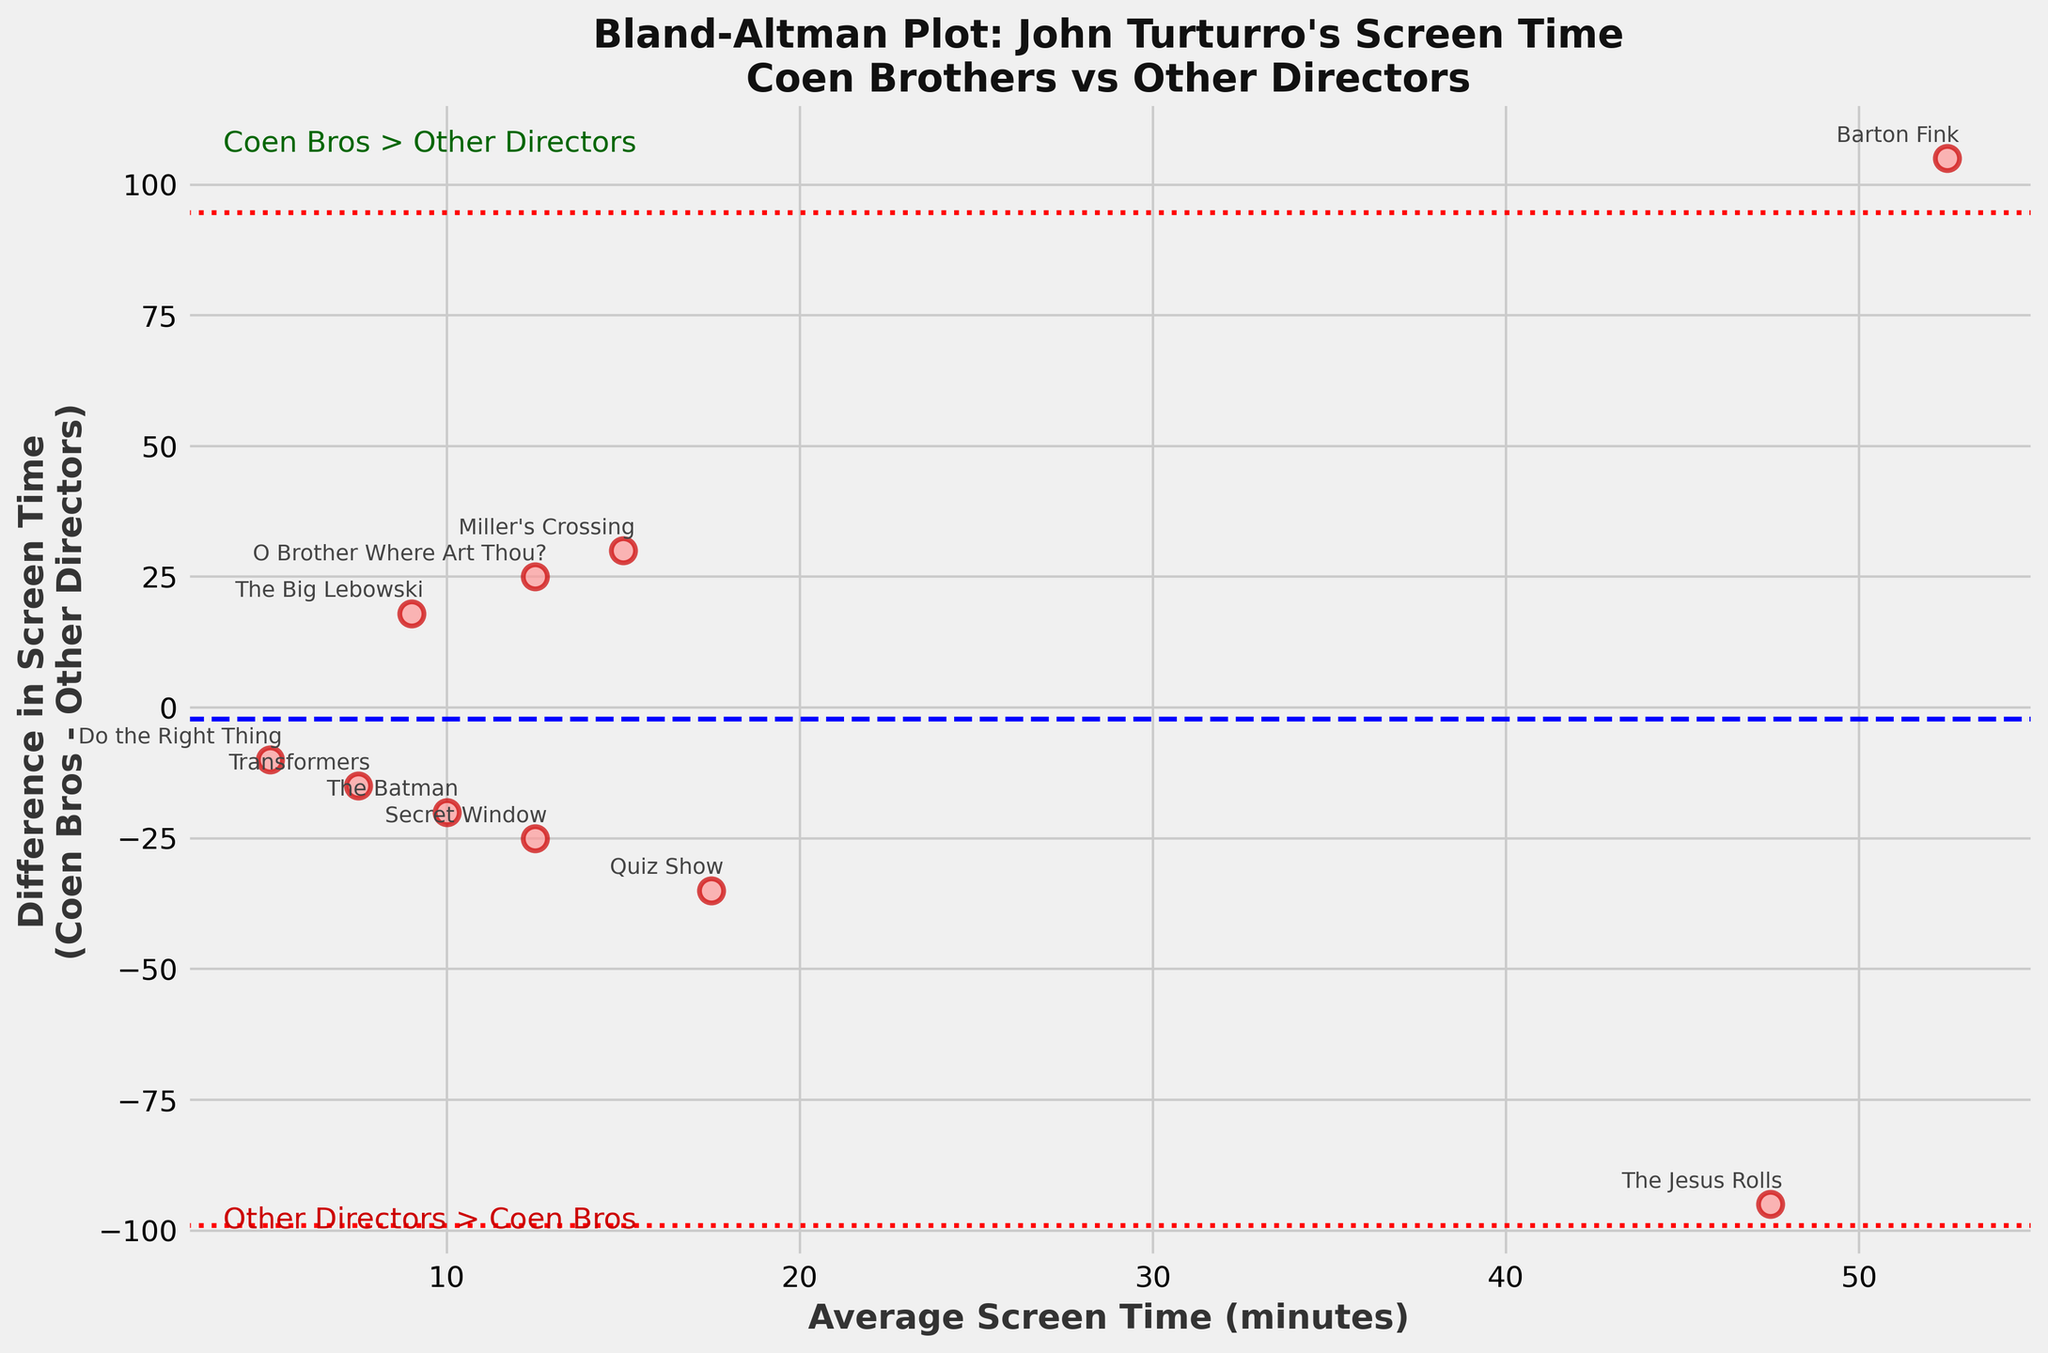What is the title of the plot? The title is located at the top of the plot and reads, "Bland-Altman Plot: John Turturro's Screen Time\nCoen Brothers vs Other Directors".
Answer: Bland-Altman Plot: John Turturro's Screen Time\nCoen Brothers vs Other Directors How many data points are plotted? Each movie represents a data point, and we can count them. There are 10 movie titles annotated.
Answer: 10 Which movie has the highest positive difference in screen time? Look at the point with the highest positive value on the y-axis. "The Jesus Rolls" is at the highest positive y-value.
Answer: The Jesus Rolls What is the average screen time for "Barton Fink"? Refer to the x-axis value where "Barton Fink" is annotated. The label shows the average is 52.5 minutes.
Answer: 52.5 minutes How is the difference calculated in the plot? The y-axis represents "Difference in Screen Time\n(Coen Bros - Other Directors)" which indicates it's calculated by subtracting other directors' screen time from Coen Brothers' screen time.
Answer: Coen Bros - Other Directors Are there any movies where John Turturro has zero screen time from either Coen Brothers or other directors? Look at the points on the y-axis at 0. These represent movies where screen time in one set is zero. "The Big Lebowski," "O Brother Where Art Thou?," "Barton Fink," "Miller's Crossing," and "The Jesus Rolls" are such movies.
Answer: Yes Which movie has the largest negative difference in screen time? Look at the point with the highest negative value on the y-axis. "The Jesus Rolls" is at the largest negative y-value.
Answer: The Jesus Rolls What is the overall mean difference in screen time between the Coen Brothers and other directors? The overall mean difference is represented by the horizontal dashed line on the plot.
Answer: Negative Does John Turturro generally have more screen time in Coen Brothers' films or in films by other directors? By observing the plot, most data points are above the x-axis which indicates a positive difference value, meaning more screen time in Coen Brothers' films.
Answer: Coen Brothers' films Are any data points outside the 95% confidence limits? The horizontal dotted lines represent ±1.96 standard deviations from the mean difference, forming the 95% confidence interval. Check if any points are outside these lines. All points fit within these lines.
Answer: No 